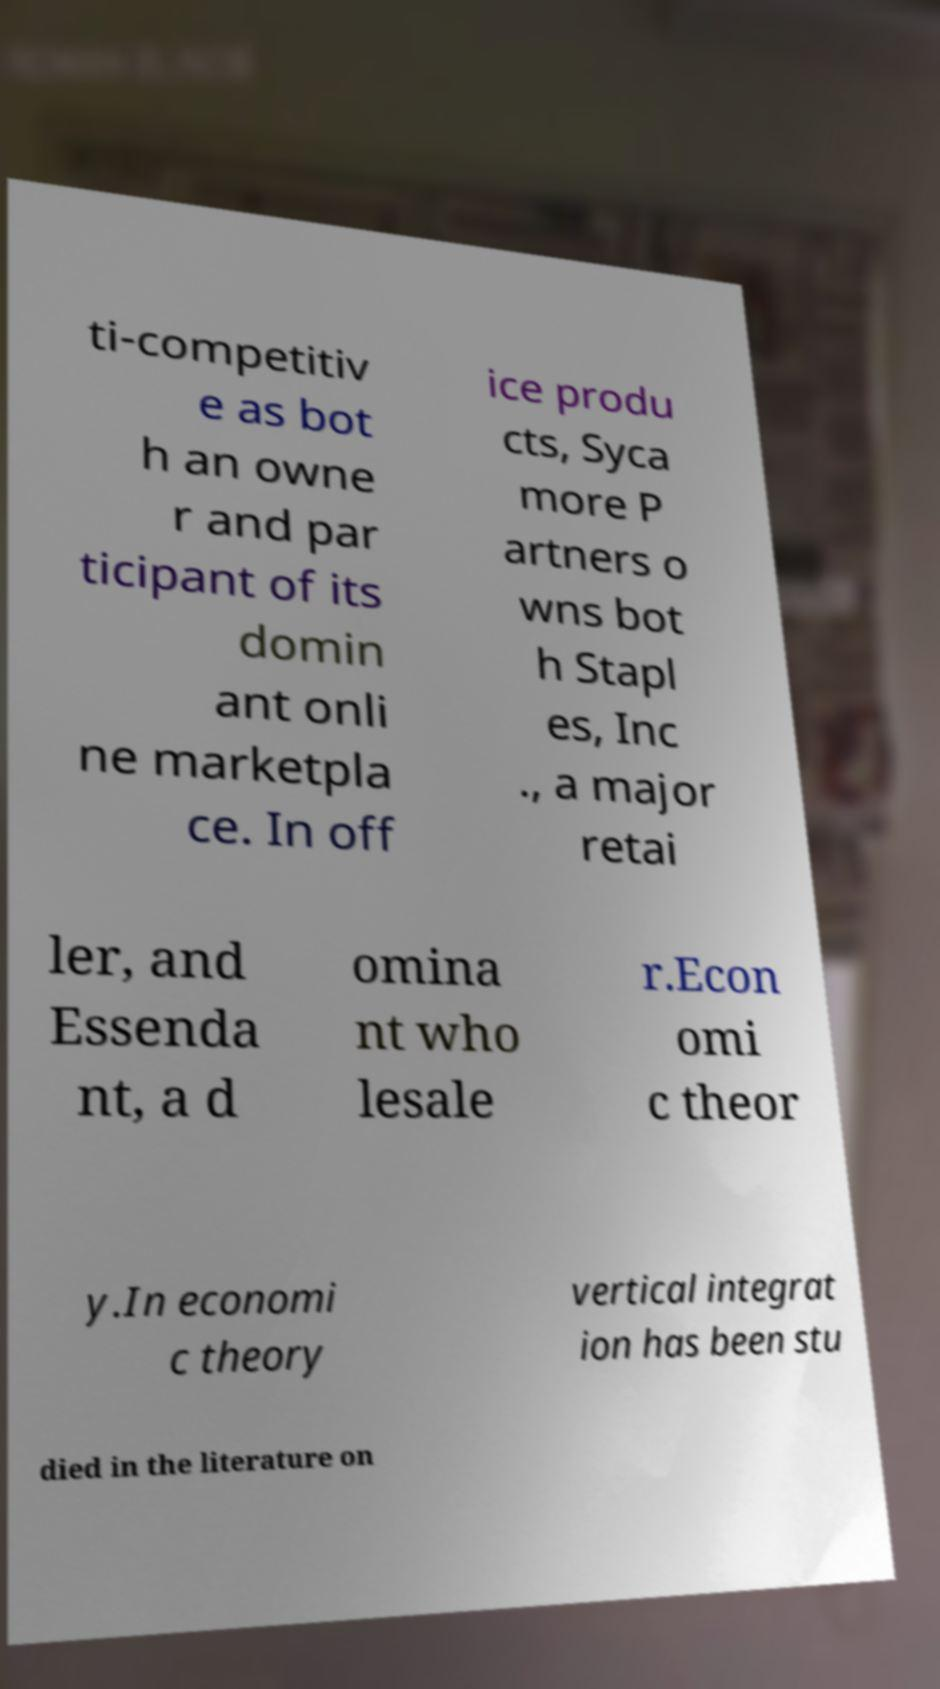There's text embedded in this image that I need extracted. Can you transcribe it verbatim? ti-competitiv e as bot h an owne r and par ticipant of its domin ant onli ne marketpla ce. In off ice produ cts, Syca more P artners o wns bot h Stapl es, Inc ., a major retai ler, and Essenda nt, a d omina nt who lesale r.Econ omi c theor y.In economi c theory vertical integrat ion has been stu died in the literature on 